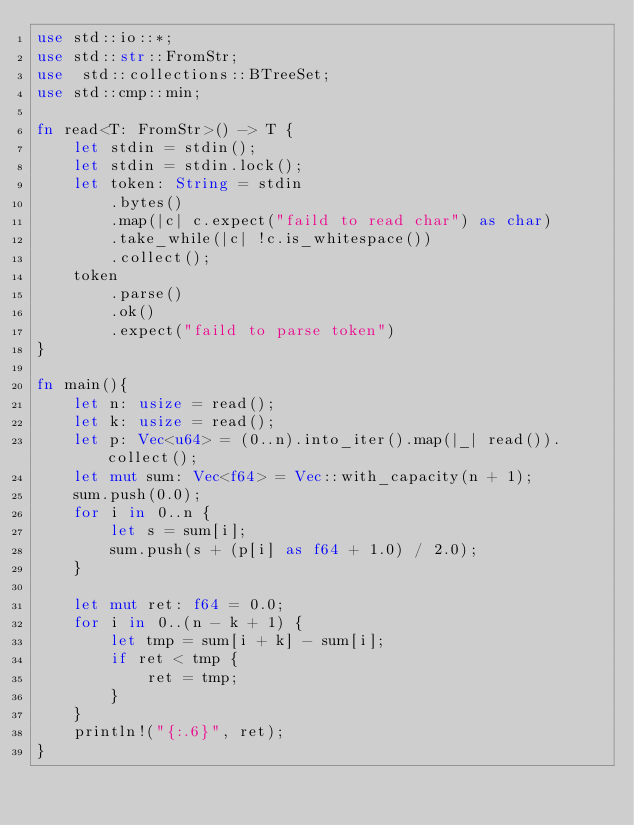<code> <loc_0><loc_0><loc_500><loc_500><_Rust_>use std::io::*;
use std::str::FromStr;
use  std::collections::BTreeSet;
use std::cmp::min;

fn read<T: FromStr>() -> T {
    let stdin = stdin();
    let stdin = stdin.lock();
    let token: String = stdin
        .bytes()
        .map(|c| c.expect("faild to read char") as char)
        .take_while(|c| !c.is_whitespace())
        .collect();
    token
        .parse()
        .ok()
        .expect("faild to parse token")
}

fn main(){
    let n: usize = read();
    let k: usize = read();
    let p: Vec<u64> = (0..n).into_iter().map(|_| read()).collect();
    let mut sum: Vec<f64> = Vec::with_capacity(n + 1);
    sum.push(0.0);
    for i in 0..n {
        let s = sum[i];
        sum.push(s + (p[i] as f64 + 1.0) / 2.0);
    }

    let mut ret: f64 = 0.0;
    for i in 0..(n - k + 1) {
        let tmp = sum[i + k] - sum[i];
        if ret < tmp {
            ret = tmp;
        }
    }
    println!("{:.6}", ret);
}
</code> 